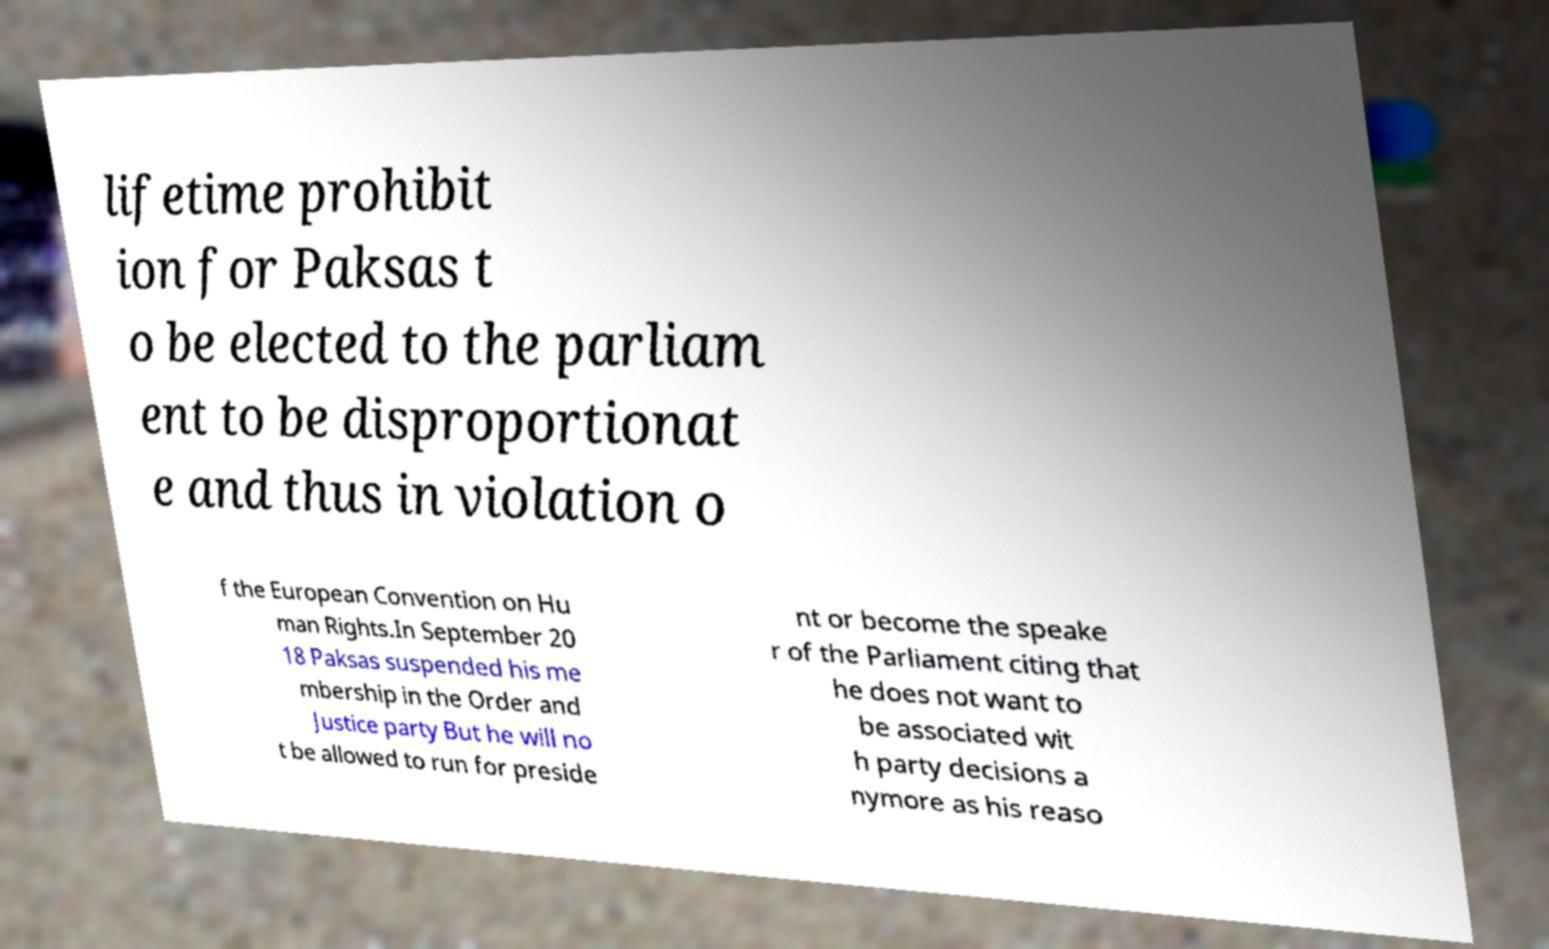What messages or text are displayed in this image? I need them in a readable, typed format. lifetime prohibit ion for Paksas t o be elected to the parliam ent to be disproportionat e and thus in violation o f the European Convention on Hu man Rights.In September 20 18 Paksas suspended his me mbership in the Order and Justice party But he will no t be allowed to run for preside nt or become the speake r of the Parliament citing that he does not want to be associated wit h party decisions a nymore as his reaso 